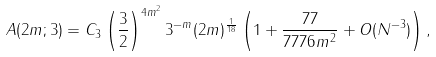Convert formula to latex. <formula><loc_0><loc_0><loc_500><loc_500>A ( 2 m ; 3 ) = C _ { 3 } \left ( \frac { 3 } { 2 } \right ) ^ { 4 m ^ { 2 } } 3 ^ { - m } ( 2 m ) ^ { \frac { 1 } { 1 8 } } \left ( 1 + \frac { 7 7 } { 7 7 7 6 m ^ { 2 } } + O ( N ^ { - 3 } ) \right ) ,</formula> 